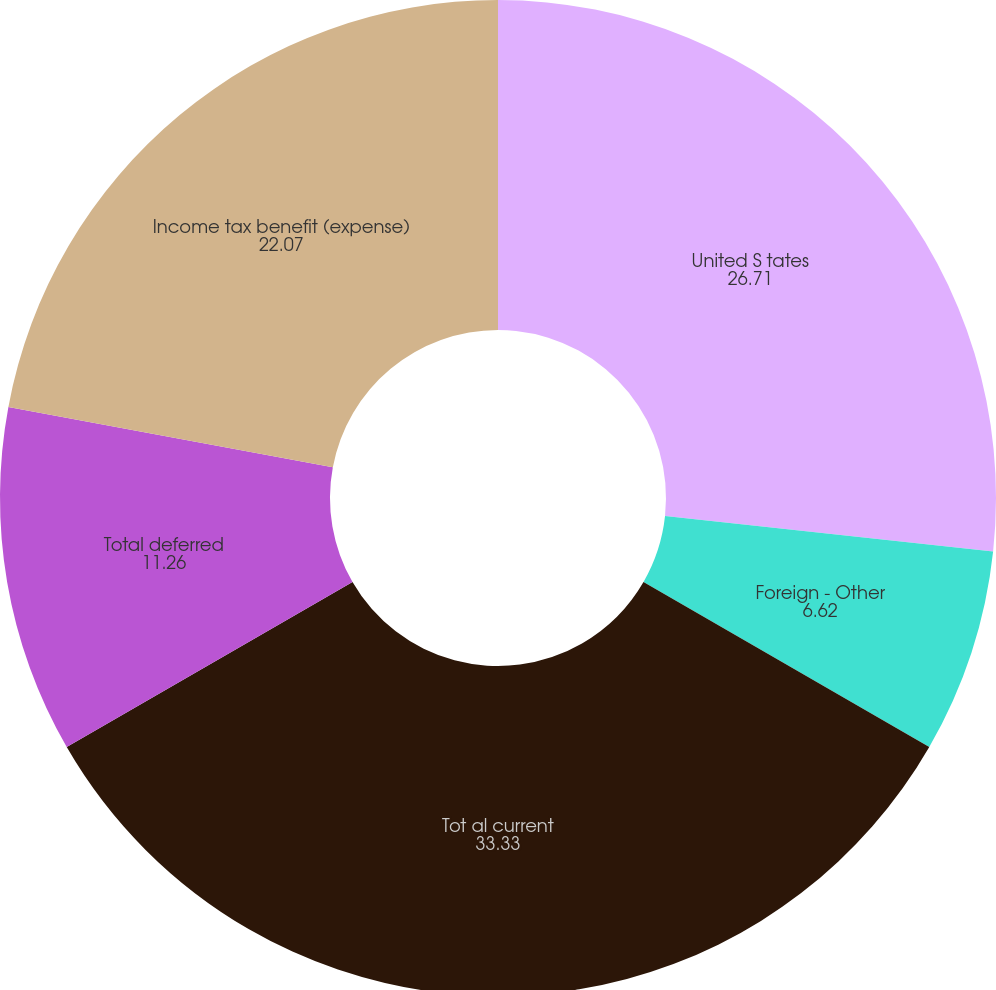Convert chart to OTSL. <chart><loc_0><loc_0><loc_500><loc_500><pie_chart><fcel>United S tates<fcel>Foreign - Other<fcel>Tot al current<fcel>Total deferred<fcel>Income tax benefit (expense)<nl><fcel>26.71%<fcel>6.62%<fcel>33.33%<fcel>11.26%<fcel>22.07%<nl></chart> 